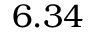Convert formula to latex. <formula><loc_0><loc_0><loc_500><loc_500>6 . 3 4</formula> 